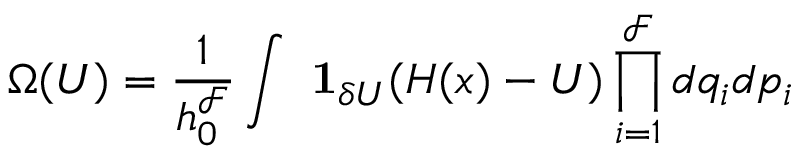Convert formula to latex. <formula><loc_0><loc_0><loc_500><loc_500>\Omega ( U ) = { \frac { 1 } { h _ { 0 } ^ { \mathcal { F } } } } \int \ 1 _ { \delta U } ( H ( x ) - U ) \prod _ { i = 1 } ^ { \mathcal { F } } d q _ { i } d p _ { i }</formula> 